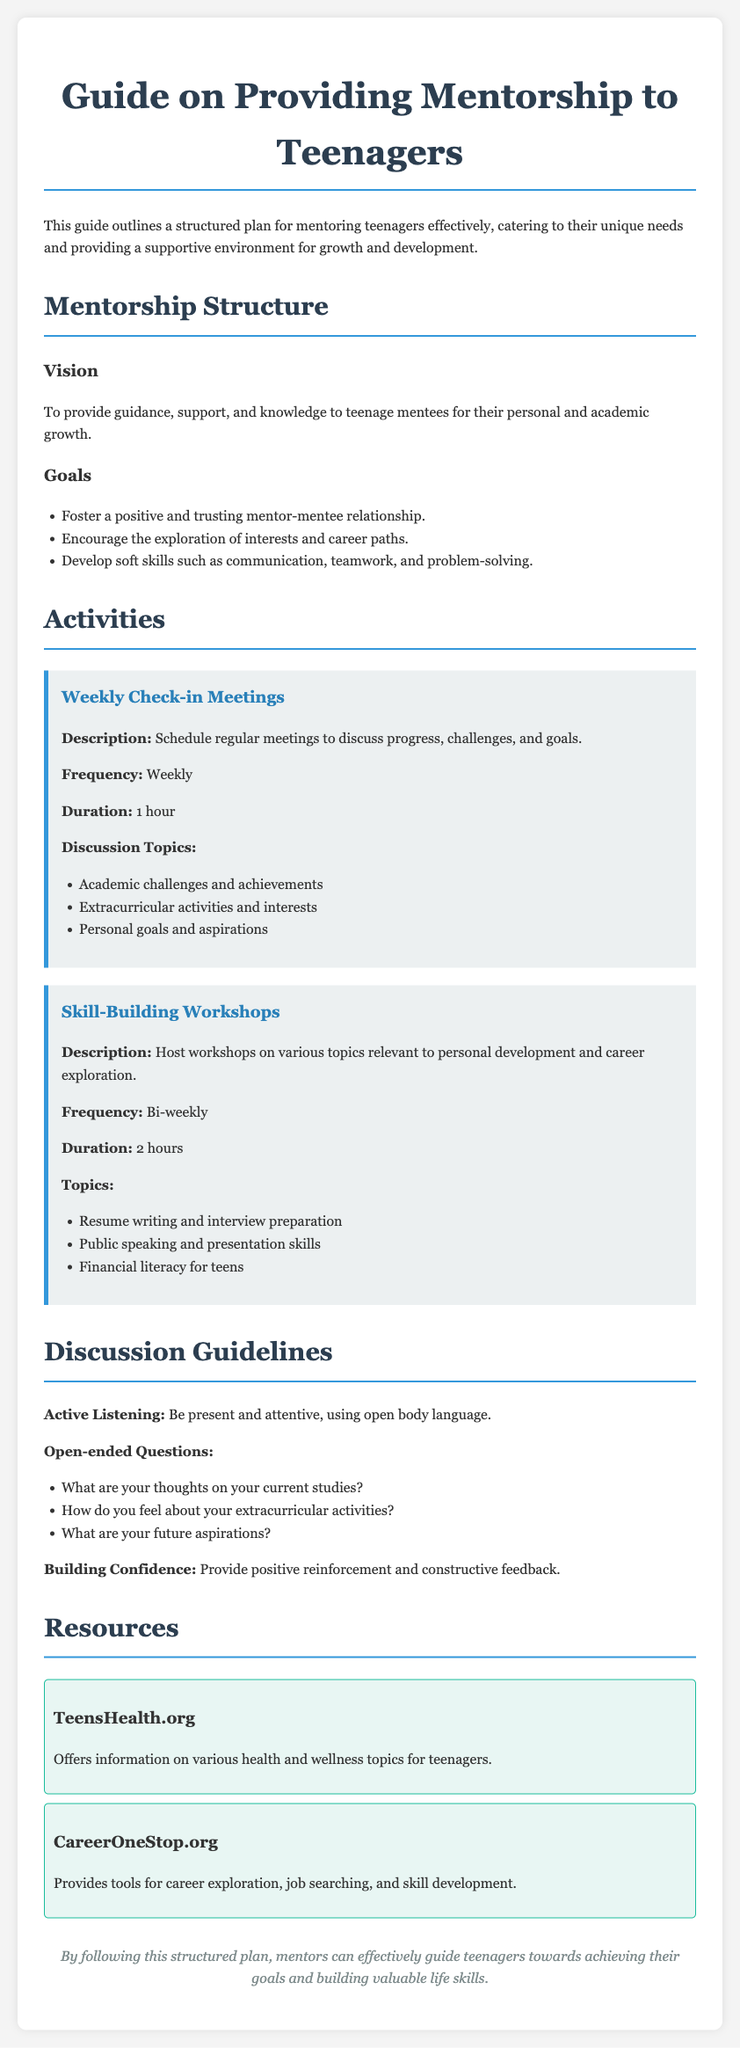what is the title of the document? The title of the document is presented prominently at the top of the rendered page.
Answer: Guide on Providing Mentorship to Teenagers how many goals are outlined in the mentorship structure? The document lists three specific goals under the mentorship structure.
Answer: 3 what is the frequency of the weekly check-in meetings? The frequency of the meetings is stated clearly in the activities section.
Answer: Weekly how long is each skill-building workshop scheduled to last? The duration of the workshops is mentioned in the description of the activities section.
Answer: 2 hours what kind of questions are recommended to use during discussions? The document suggests using open-ended questions as part of the discussion guidelines.
Answer: Open-ended questions what is the main vision for the mentorship program? The vision is stated explicitly in the mentorship structure section of the document.
Answer: To provide guidance, support, and knowledge what resource is provided for health and wellness topics? The document lists a specific resource that focuses on health and wellness.
Answer: TeensHealth.org what is the purpose of the skill-building workshops? The purpose is provided in the description of the activity in the document.
Answer: Personal development and career exploration 